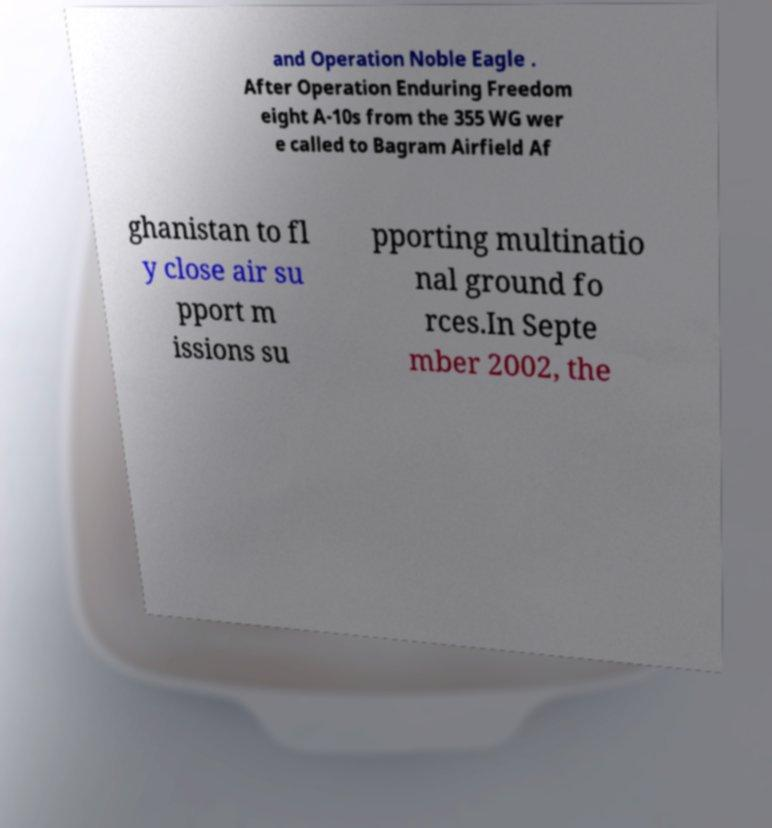Can you accurately transcribe the text from the provided image for me? and Operation Noble Eagle . After Operation Enduring Freedom eight A-10s from the 355 WG wer e called to Bagram Airfield Af ghanistan to fl y close air su pport m issions su pporting multinatio nal ground fo rces.In Septe mber 2002, the 